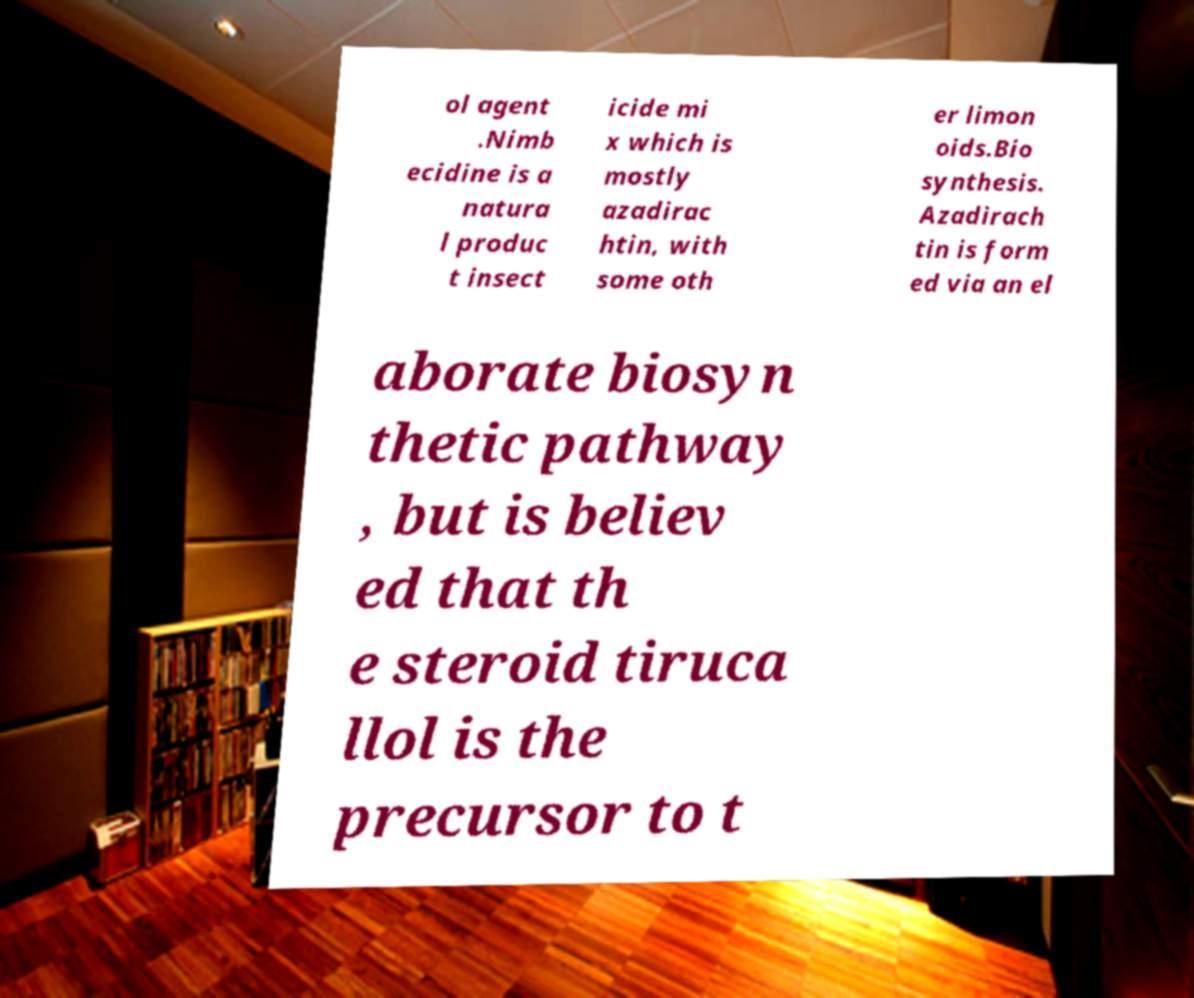There's text embedded in this image that I need extracted. Can you transcribe it verbatim? ol agent .Nimb ecidine is a natura l produc t insect icide mi x which is mostly azadirac htin, with some oth er limon oids.Bio synthesis. Azadirach tin is form ed via an el aborate biosyn thetic pathway , but is believ ed that th e steroid tiruca llol is the precursor to t 